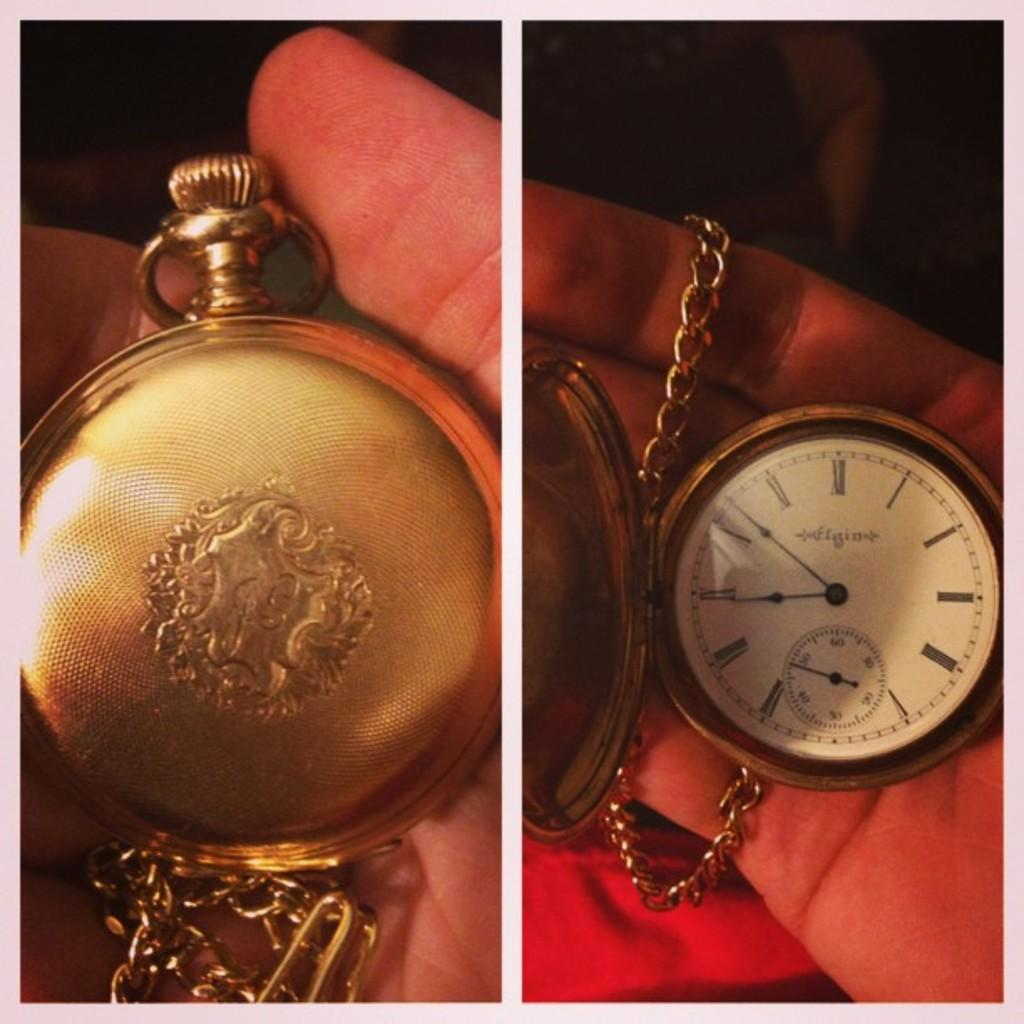Provide a one-sentence caption for the provided image. An Elgin pocket watch is displayed both closed and open. 